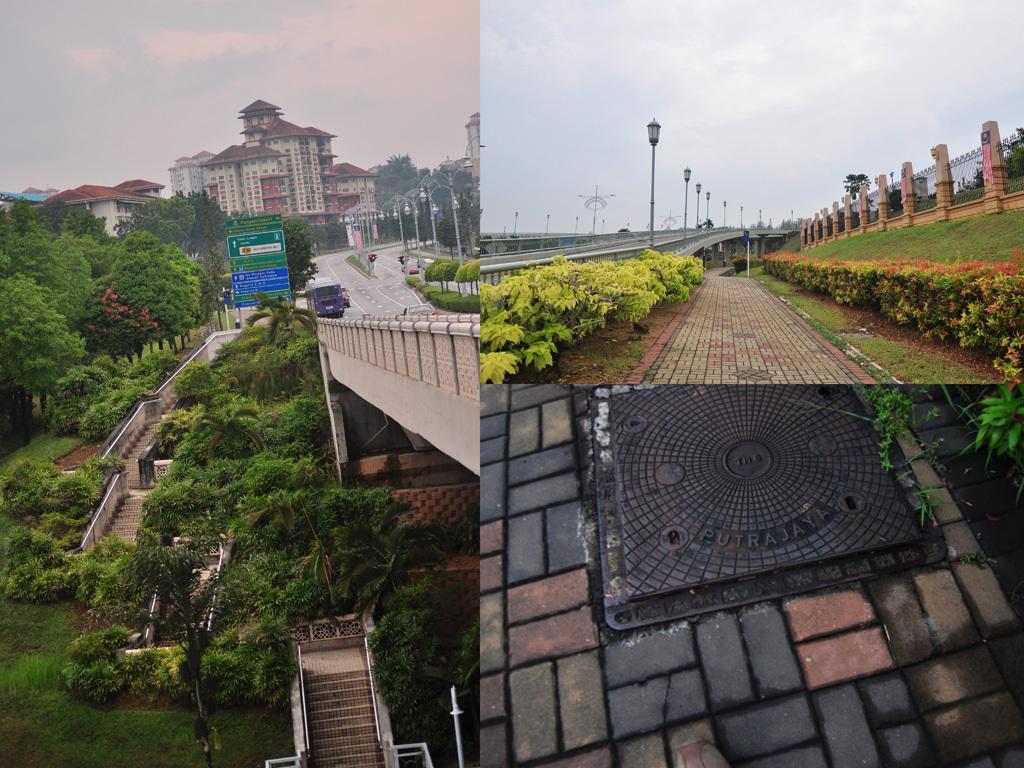Can you describe this image briefly? This image is a collage and in this image we can see the buildings, trees, stairs, plants, grass, light poles, road, vehicles, sign boards, a manhole cover, fence and also the sky with some clouds. 